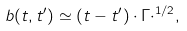Convert formula to latex. <formula><loc_0><loc_0><loc_500><loc_500>b ( t , t ^ { \prime } ) \simeq ( t - t ^ { \prime } ) \cdot \Gamma \cdot ^ { 1 / 2 } ,</formula> 